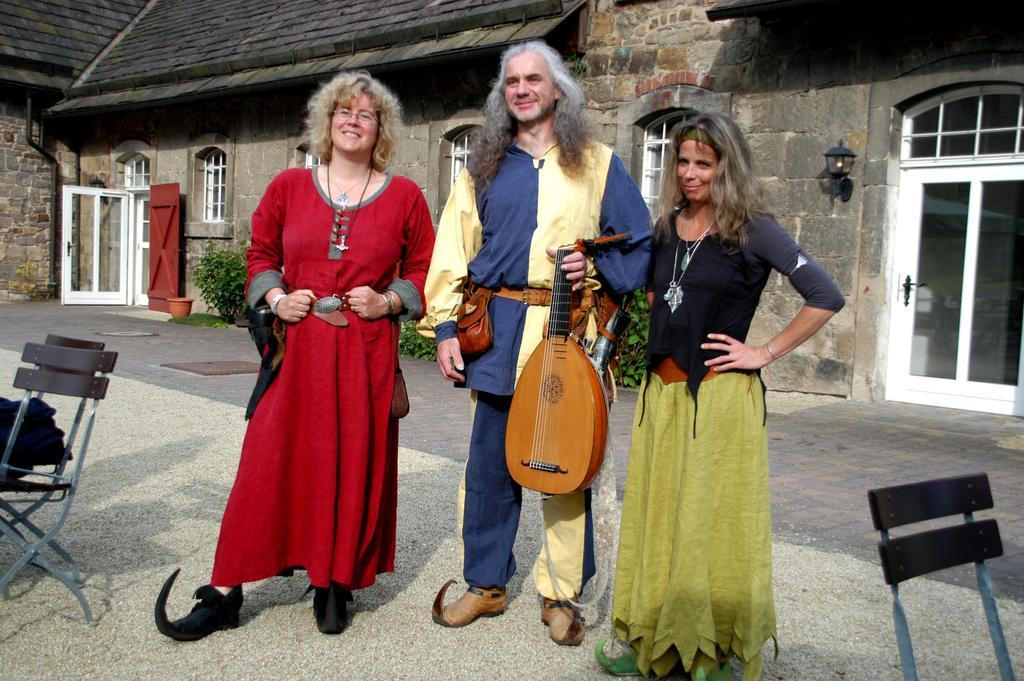In one or two sentences, can you explain what this image depicts? Here in this picture we can see three people standing on the ground over there and we can see all of them are smiling, wearing different costumes on them and the person in the middle is holding a musical instrument in his hand and beside them on either side we can see chairs present and behind them we can see a house present as we can see doors and windows on it over there and we can see lamp pots and plants present over there. 